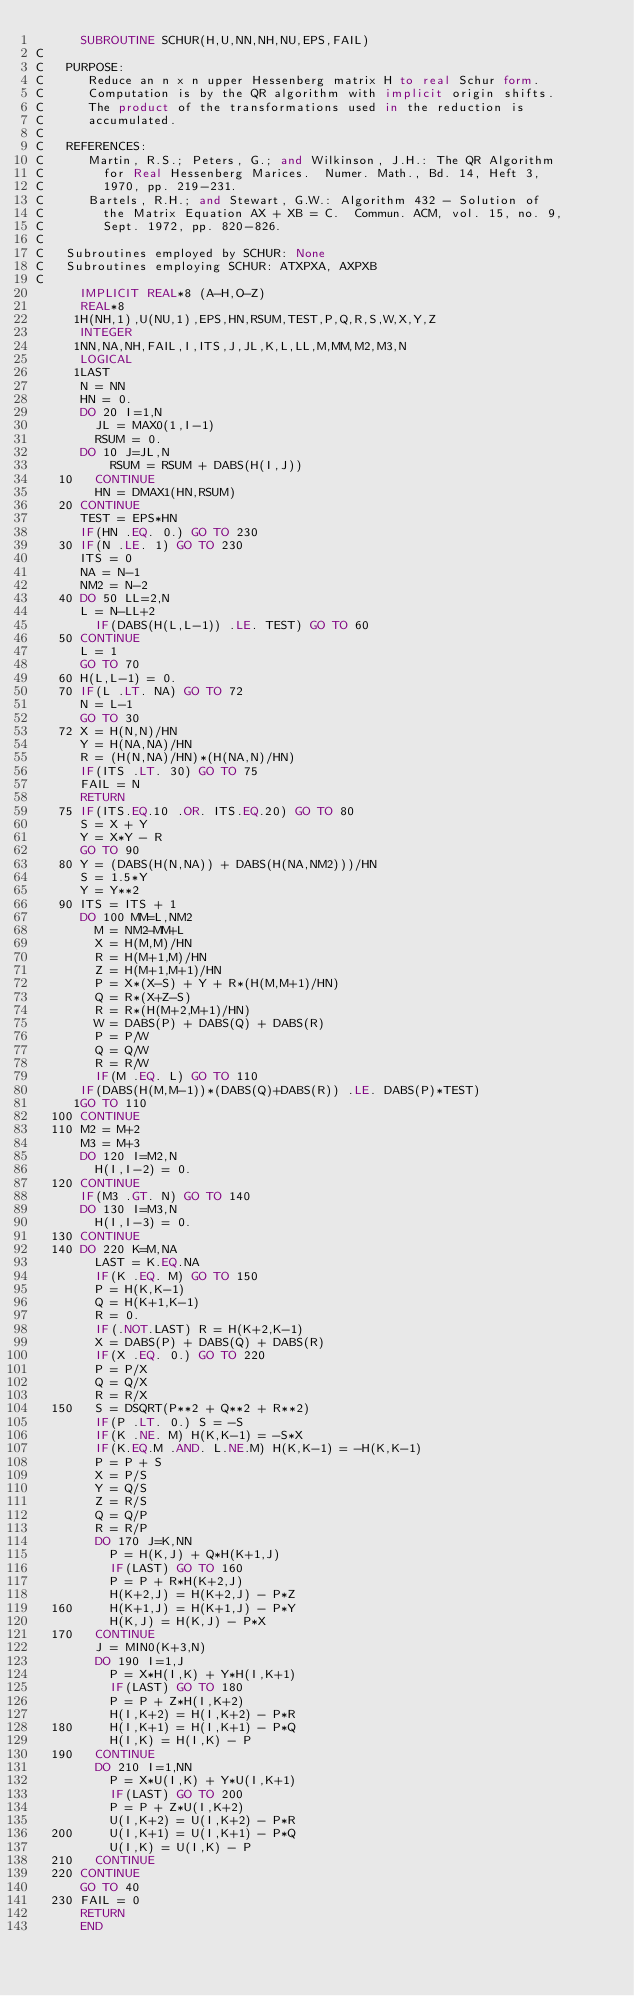<code> <loc_0><loc_0><loc_500><loc_500><_FORTRAN_>      SUBROUTINE SCHUR(H,U,NN,NH,NU,EPS,FAIL)
C 
C   PURPOSE:
C      Reduce an n x n upper Hessenberg matrix H to real Schur form.
C      Computation is by the QR algorithm with implicit origin shifts.
C      The product of the transformations used in the reduction is
C      accumulated.
C 
C   REFERENCES:
C      Martin, R.S.; Peters, G.; and Wilkinson, J.H.: The QR Algorithm
C        for Real Hessenberg Marices.  Numer. Math., Bd. 14, Heft 3,
C        1970, pp. 219-231.
C      Bartels, R.H.; and Stewart, G.W.: Algorithm 432 - Solution of
C        the Matrix Equation AX + XB = C.  Commun. ACM, vol. 15, no. 9,
C        Sept. 1972, pp. 820-826.
C 
C   Subroutines employed by SCHUR: None
C   Subroutines employing SCHUR: ATXPXA, AXPXB
C 
      IMPLICIT REAL*8 (A-H,O-Z)
      REAL*8
     1H(NH,1),U(NU,1),EPS,HN,RSUM,TEST,P,Q,R,S,W,X,Y,Z
      INTEGER
     1NN,NA,NH,FAIL,I,ITS,J,JL,K,L,LL,M,MM,M2,M3,N
      LOGICAL
     1LAST
      N = NN
      HN = 0.
      DO 20 I=1,N
        JL = MAX0(1,I-1)
        RSUM = 0.
      DO 10 J=JL,N
          RSUM = RSUM + DABS(H(I,J))
   10   CONTINUE
        HN = DMAX1(HN,RSUM)
   20 CONTINUE
      TEST = EPS*HN
      IF(HN .EQ. 0.) GO TO 230
   30 IF(N .LE. 1) GO TO 230
      ITS = 0
      NA = N-1
      NM2 = N-2
   40 DO 50 LL=2,N
      L = N-LL+2
        IF(DABS(H(L,L-1)) .LE. TEST) GO TO 60
   50 CONTINUE
      L = 1
      GO TO 70
   60 H(L,L-1) = 0.
   70 IF(L .LT. NA) GO TO 72
      N = L-1
      GO TO 30
   72 X = H(N,N)/HN
      Y = H(NA,NA)/HN
      R = (H(N,NA)/HN)*(H(NA,N)/HN)
      IF(ITS .LT. 30) GO TO 75
      FAIL = N
      RETURN
   75 IF(ITS.EQ.10 .OR. ITS.EQ.20) GO TO 80
      S = X + Y
      Y = X*Y - R
      GO TO 90
   80 Y = (DABS(H(N,NA)) + DABS(H(NA,NM2)))/HN
      S = 1.5*Y
      Y = Y**2
   90 ITS = ITS + 1
      DO 100 MM=L,NM2
        M = NM2-MM+L
        X = H(M,M)/HN
        R = H(M+1,M)/HN
        Z = H(M+1,M+1)/HN
        P = X*(X-S) + Y + R*(H(M,M+1)/HN)
        Q = R*(X+Z-S)
        R = R*(H(M+2,M+1)/HN)
        W = DABS(P) + DABS(Q) + DABS(R)
        P = P/W
        Q = Q/W
        R = R/W
        IF(M .EQ. L) GO TO 110
      IF(DABS(H(M,M-1))*(DABS(Q)+DABS(R)) .LE. DABS(P)*TEST)
     1GO TO 110
  100 CONTINUE
  110 M2 = M+2
      M3 = M+3
      DO 120 I=M2,N
        H(I,I-2) = 0.
  120 CONTINUE
      IF(M3 .GT. N) GO TO 140
      DO 130 I=M3,N
        H(I,I-3) = 0.
  130 CONTINUE
  140 DO 220 K=M,NA
        LAST = K.EQ.NA
        IF(K .EQ. M) GO TO 150
        P = H(K,K-1)
        Q = H(K+1,K-1)
        R = 0.
        IF(.NOT.LAST) R = H(K+2,K-1)
        X = DABS(P) + DABS(Q) + DABS(R)
        IF(X .EQ. 0.) GO TO 220
        P = P/X
        Q = Q/X
        R = R/X
  150   S = DSQRT(P**2 + Q**2 + R**2)
        IF(P .LT. 0.) S = -S
        IF(K .NE. M) H(K,K-1) = -S*X
        IF(K.EQ.M .AND. L.NE.M) H(K,K-1) = -H(K,K-1)
        P = P + S
        X = P/S
        Y = Q/S
        Z = R/S
        Q = Q/P
        R = R/P
        DO 170 J=K,NN
          P = H(K,J) + Q*H(K+1,J)
          IF(LAST) GO TO 160
          P = P + R*H(K+2,J)
          H(K+2,J) = H(K+2,J) - P*Z
  160     H(K+1,J) = H(K+1,J) - P*Y
          H(K,J) = H(K,J) - P*X
  170   CONTINUE
        J = MIN0(K+3,N)
        DO 190 I=1,J
          P = X*H(I,K) + Y*H(I,K+1)
          IF(LAST) GO TO 180
          P = P + Z*H(I,K+2)
          H(I,K+2) = H(I,K+2) - P*R
  180     H(I,K+1) = H(I,K+1) - P*Q
          H(I,K) = H(I,K) - P
  190   CONTINUE
        DO 210 I=1,NN
          P = X*U(I,K) + Y*U(I,K+1)
          IF(LAST) GO TO 200
          P = P + Z*U(I,K+2)
          U(I,K+2) = U(I,K+2) - P*R
  200     U(I,K+1) = U(I,K+1) - P*Q
          U(I,K) = U(I,K) - P
  210   CONTINUE
  220 CONTINUE
      GO TO 40
  230 FAIL = 0
      RETURN
      END
</code> 